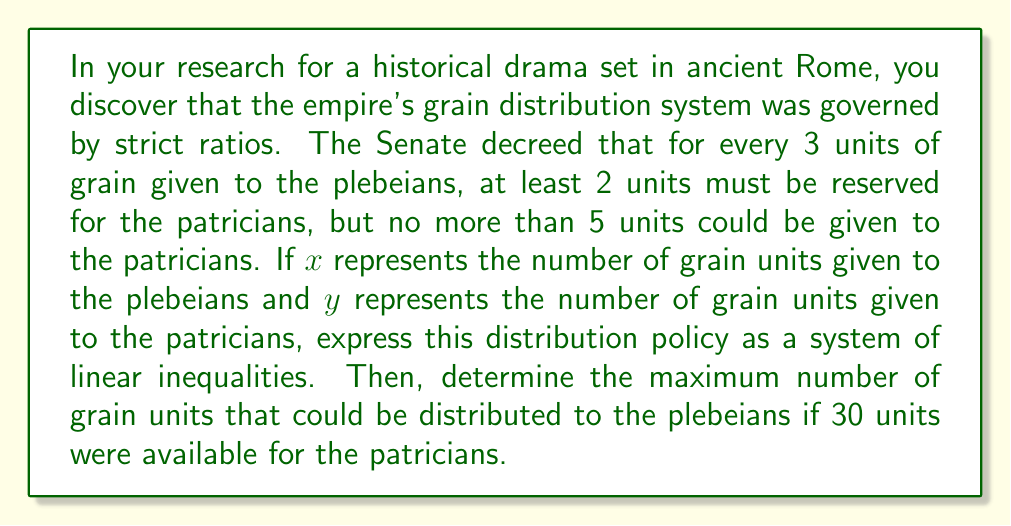Give your solution to this math problem. Let's approach this step-by-step:

1) First, we need to express the ratios as linear inequalities:

   - At least 2 units for patricians for every 3 units for plebeians:
     $$y \geq \frac{2}{3}x$$

   - No more than 5 units for patricians for every 3 units for plebeians:
     $$y \leq \frac{5}{3}x$$

2) We also know that the quantities can't be negative:
   $$x \geq 0$$ and $$y \geq 0$$

3) So, our system of linear inequalities is:
   $$\begin{cases}
   y \geq \frac{2}{3}x \\
   y \leq \frac{5}{3}x \\
   x \geq 0 \\
   y \geq 0
   \end{cases}$$

4) Now, to find the maximum number of grain units for plebeians when 30 units are available for patricians, we set $y = 30$ and solve for $x$ using the first inequality:

   $$30 \geq \frac{2}{3}x$$

5) Multiply both sides by $\frac{3}{2}$:

   $$45 \geq x$$

Therefore, the maximum number of grain units that could be distributed to the plebeians is 45 units.
Answer: The system of linear inequalities is:
$$\begin{cases}
y \geq \frac{2}{3}x \\
y \leq \frac{5}{3}x \\
x \geq 0 \\
y \geq 0
\end{cases}$$

The maximum number of grain units for plebeians when 30 units are available for patricians is 45 units. 